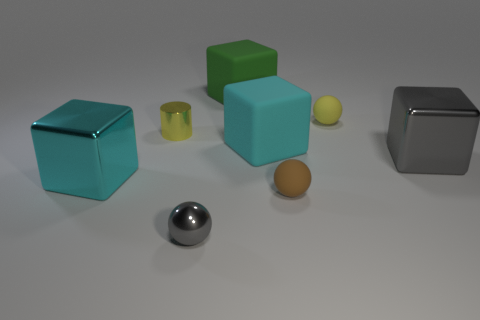Subtract 1 cubes. How many cubes are left? 3 Add 2 small metal cylinders. How many objects exist? 10 Subtract all cylinders. How many objects are left? 7 Add 5 yellow metal objects. How many yellow metal objects exist? 6 Subtract 1 yellow spheres. How many objects are left? 7 Subtract all tiny rubber spheres. Subtract all small yellow matte things. How many objects are left? 5 Add 5 small gray objects. How many small gray objects are left? 6 